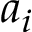Convert formula to latex. <formula><loc_0><loc_0><loc_500><loc_500>a _ { i }</formula> 